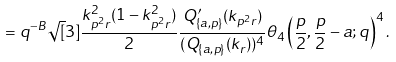Convert formula to latex. <formula><loc_0><loc_0><loc_500><loc_500>= q ^ { - B } \sqrt { [ } 3 ] { \frac { k _ { p ^ { 2 } r } ^ { 2 } ( 1 - k _ { p ^ { 2 } r } ^ { 2 } ) } { 2 } } \frac { Q _ { \{ a , p \} } ^ { \prime } ( k _ { p ^ { 2 } r } ) } { ( Q _ { \{ a , p \} } ( k _ { r } ) ) ^ { 4 } } \theta _ { 4 } \left ( \frac { p } { 2 } , \frac { p } { 2 } - a ; q \right ) ^ { 4 } .</formula> 